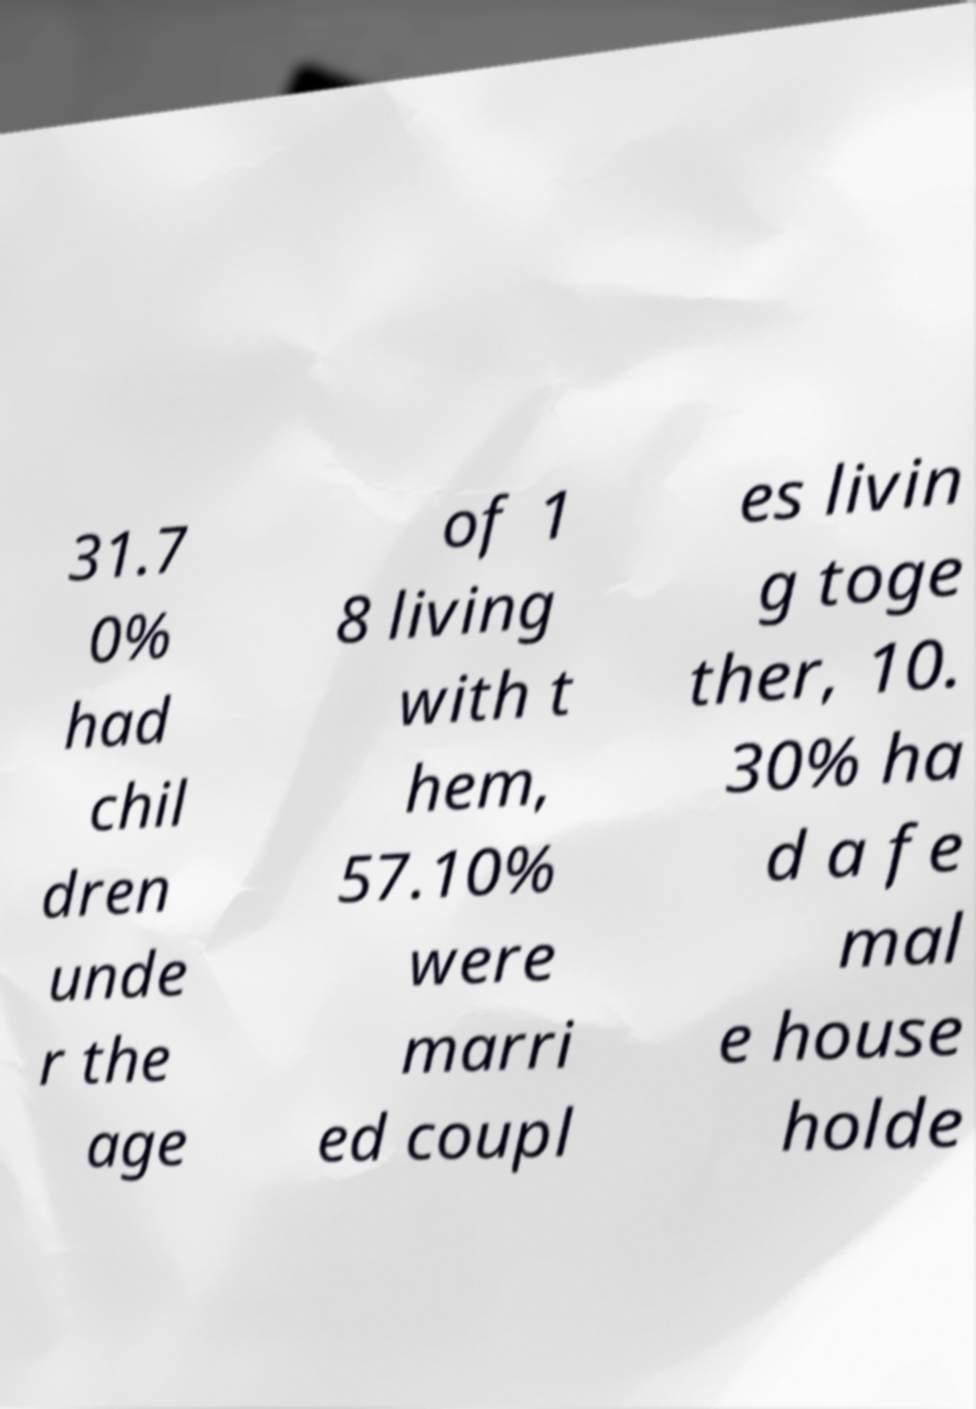There's text embedded in this image that I need extracted. Can you transcribe it verbatim? 31.7 0% had chil dren unde r the age of 1 8 living with t hem, 57.10% were marri ed coupl es livin g toge ther, 10. 30% ha d a fe mal e house holde 